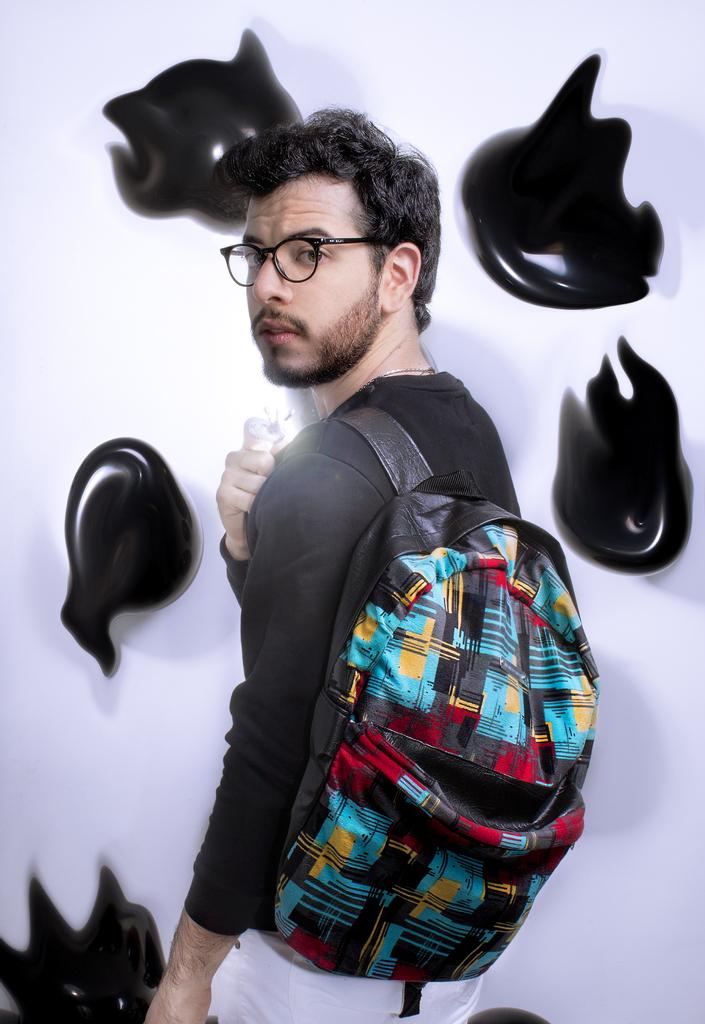What is the main subject of the image? There is a man standing in the center of the image. What is the man wearing in the image? The man is wearing a bag. What can be seen in the background of the image? There are objects hanging on the wall in the background of the image. What is the color of the objects on the wall? The objects on the wall are black in color. What type of riddle is the man holding in his hand in the image? There is no riddle visible in the man's hand in the image. 